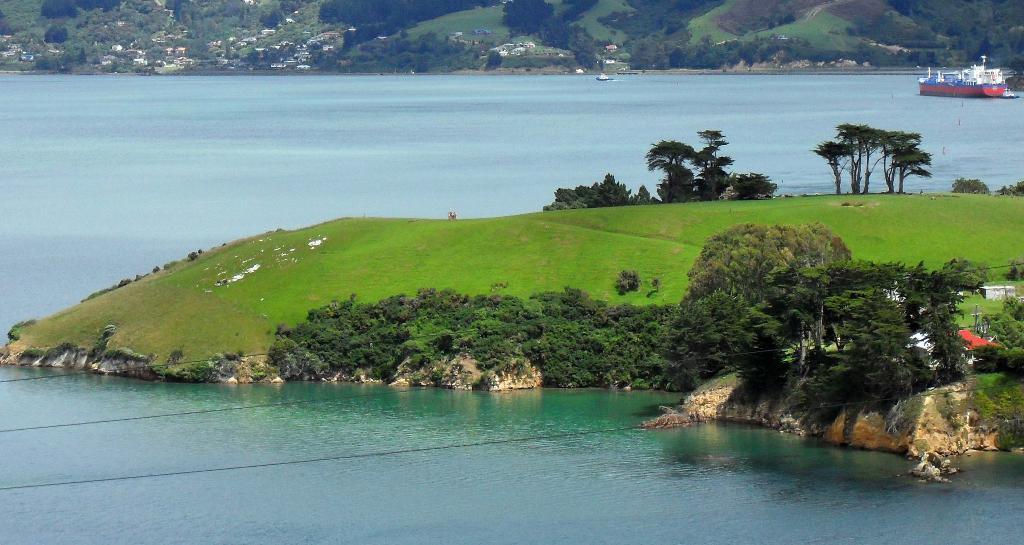How would you summarize this image in a sentence or two? In this image in the front there is water. In the center there is grass on the ground and there are trees and there are houses. In the background there is a ship on the water and there are trees, houses and there's grass on the ground. 